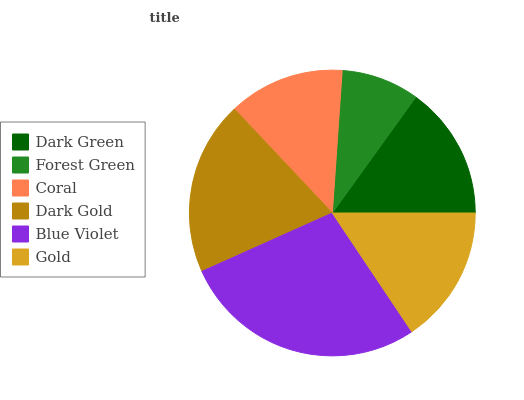Is Forest Green the minimum?
Answer yes or no. Yes. Is Blue Violet the maximum?
Answer yes or no. Yes. Is Coral the minimum?
Answer yes or no. No. Is Coral the maximum?
Answer yes or no. No. Is Coral greater than Forest Green?
Answer yes or no. Yes. Is Forest Green less than Coral?
Answer yes or no. Yes. Is Forest Green greater than Coral?
Answer yes or no. No. Is Coral less than Forest Green?
Answer yes or no. No. Is Gold the high median?
Answer yes or no. Yes. Is Dark Green the low median?
Answer yes or no. Yes. Is Forest Green the high median?
Answer yes or no. No. Is Coral the low median?
Answer yes or no. No. 